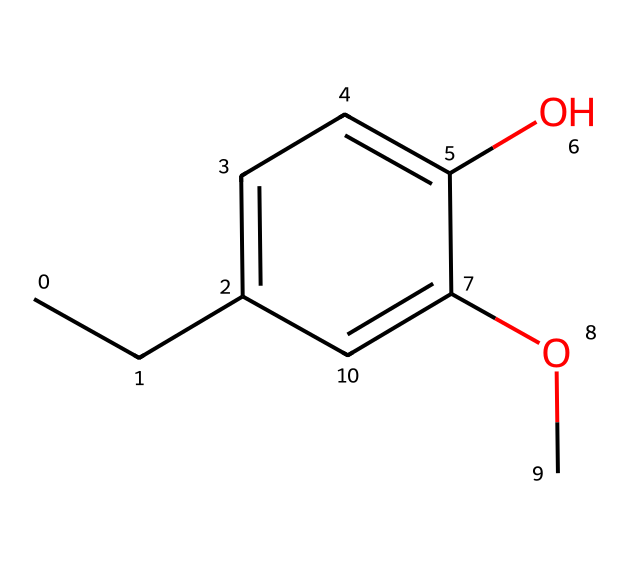How many carbon atoms are in eugenol? In the SMILES representation, each "C" represents a carbon atom. Counting the occurrences of "C" reveals there are 10 carbon atoms present.
Answer: 10 What is the functional group present in eugenol? The presence of the hydroxyl (-OH) group, indicated by the "O" next to a carbon in the structure, identifies it as an alcohol functional group.
Answer: alcohol How many double bonds does eugenol have? By analyzing the structure, we can see that eugenol contains one aromatic ring (the benzene part) which has alternating double bonds and another double bond between the aromatic ring and the side alkyl chain, totaling two double bonds.
Answer: 2 What aspect of the eugenol structure contributes to its flavor profile? The methoxy (-OCH3) and hydroxyl groups (-OH) influence the flavor profile, providing both aromatic and sweet notes as common in flavor compounds. Thus, these specific groups contribute to its distinct flavor characteristics.
Answer: methoxy and hydroxyl What type of compound is eugenol classified as? Given its structure, eugenol is classified as a phenolic compound due to the presence of the benzene ring and the hydroxyl group, which are characteristic features of phenols.
Answer: phenolic How does eugenol's structure relate to its use in spicy applications? The phenolic structure, characterized by the presence of both hydroxyl and methoxy groups, enhances its volatility and aromatic properties, making it highly effective in spicy and flavorful drinks, contributing to both taste and smell.
Answer: aromatic properties What is the boiling point range of eugenol? Eugenol typically has a boiling point between 250 and 251 degrees Celsius, which is indicated in literature due to its specific molecular structure and interactions.
Answer: 250-251 degrees Celsius 